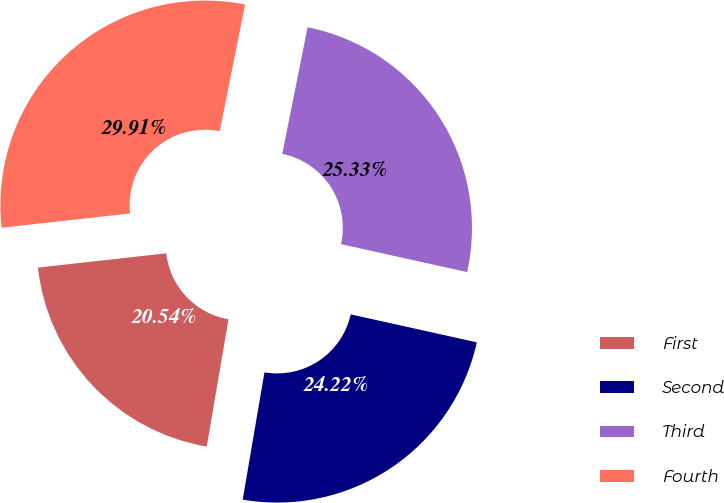Convert chart. <chart><loc_0><loc_0><loc_500><loc_500><pie_chart><fcel>First<fcel>Second<fcel>Third<fcel>Fourth<nl><fcel>20.54%<fcel>24.22%<fcel>25.33%<fcel>29.91%<nl></chart> 